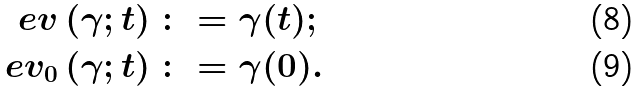Convert formula to latex. <formula><loc_0><loc_0><loc_500><loc_500>\ e v \left ( \gamma ; t \right ) \colon & = \gamma ( t ) ; \\ \ e v _ { 0 } \left ( \gamma ; t \right ) \colon & = \gamma ( 0 ) .</formula> 